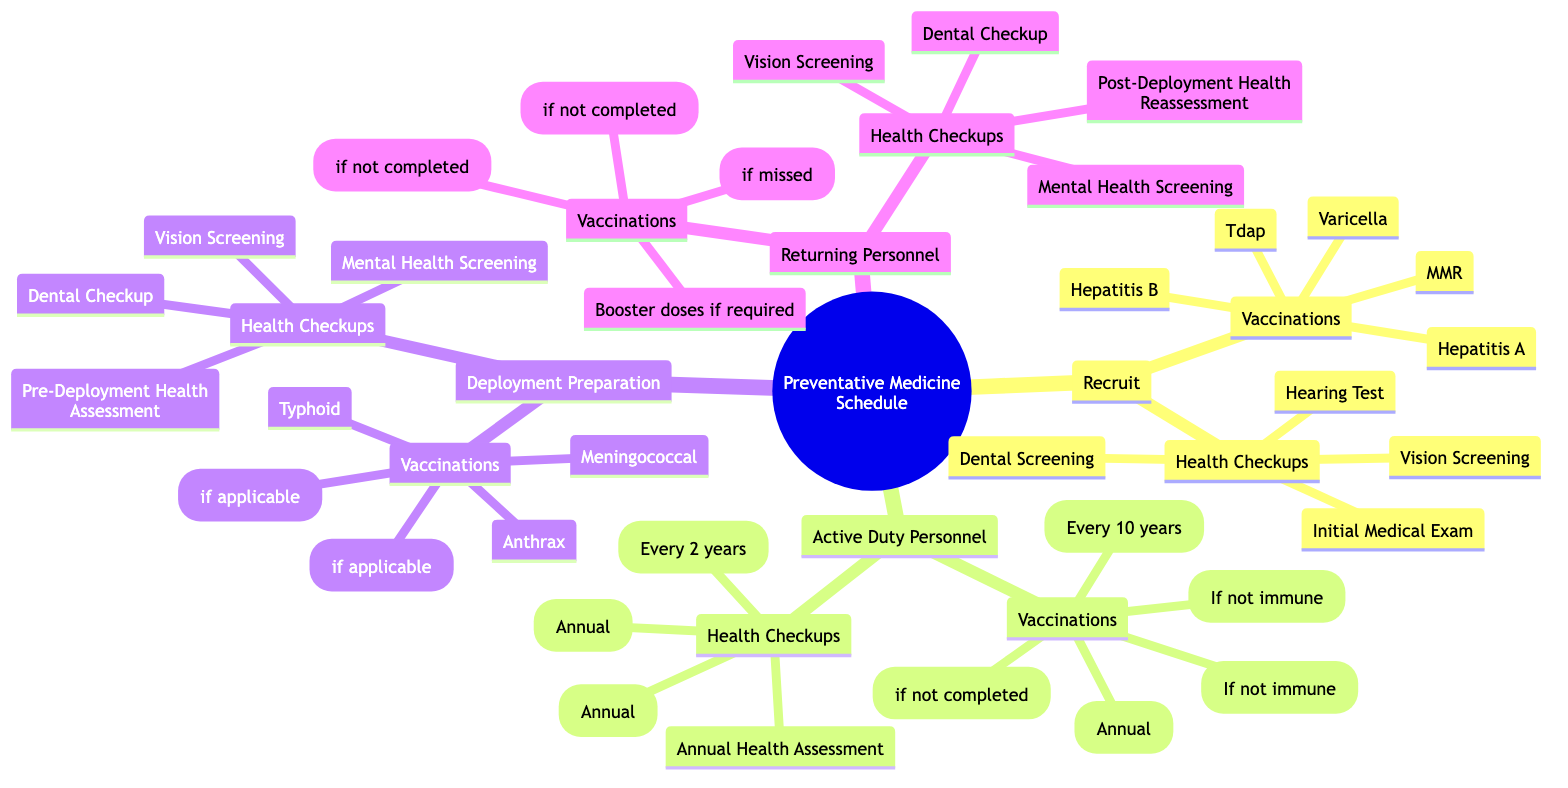What are the initial vaccinations for recruits? The diagram lists the vaccinations for recruits under the "Vaccinations" section for "Recruit." The vaccinations mentioned are Hepatitis A, Hepatitis B, MMR, Varicella, and Tdap.
Answer: Hepatitis A, Hepatitis B, MMR, Varicella, Tdap How often should active duty personnel receive a dental checkup? Looking at the "Health Checkups" section for "Active Duty Personnel," it specifies that a dental checkup should occur annually.
Answer: Annual What is the frequency of the vision screening for active duty personnel? The vision screening frequency is detailed in the "Health Checkups" section. For active duty personnel, the vision screening occurs every 2 years.
Answer: Every 2 years Which vaccinations are required for deployment preparation? The "Vaccinations" section under "Deployment Preparation" lists specific vaccinations: Anthrax, Japanese Encephalitis, Typhoid, Yellow Fever, and Meningococcal.
Answer: Anthrax, Japanese Encephalitis, Typhoid, Yellow Fever, Meningococcal What type of health assessment should be conducted prior to deployment? The diagram includes a specific health checkup titled "Pre-Deployment Health Assessment" under the "Health Checkups" section for "Deployment Preparation."
Answer: Pre-Deployment Health Assessment What vaccinations are given to returning personnel? Under the "Vaccinations" section for "Returning Personnel," it lists booster doses if required, Influenza, Hepatitis A, and Hepatitis B.
Answer: Booster doses if required, Influenza, Hepatitis A, Hepatitis B What kind of screening is required during the pre-deployment health checkup? In the "Health Checkups" section for "Deployment Preparation," it specifies that a "Mental Health Screening" is part of the health checks before deployment.
Answer: Mental Health Screening How often should the fitness test be conducted for active duty personnel? The "Health Checkups" section of "Active Duty Personnel" indicates that a fitness test is conducted annually.
Answer: Annual 